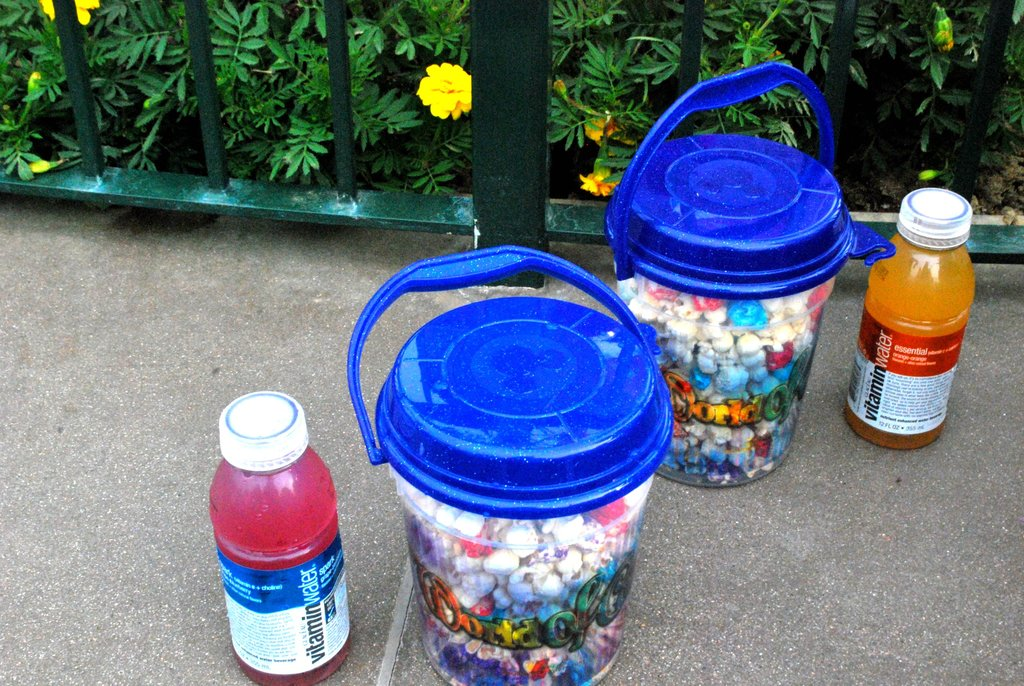Could you describe what might be the purpose of collecting these bottle caps in the buckets? The collection of bottle caps in the buckets might be a part of a recycling initiative or a craft project. Such efforts are often aimed at environmental conservation or could be used in educational settings to teach about recycling and reusability. 